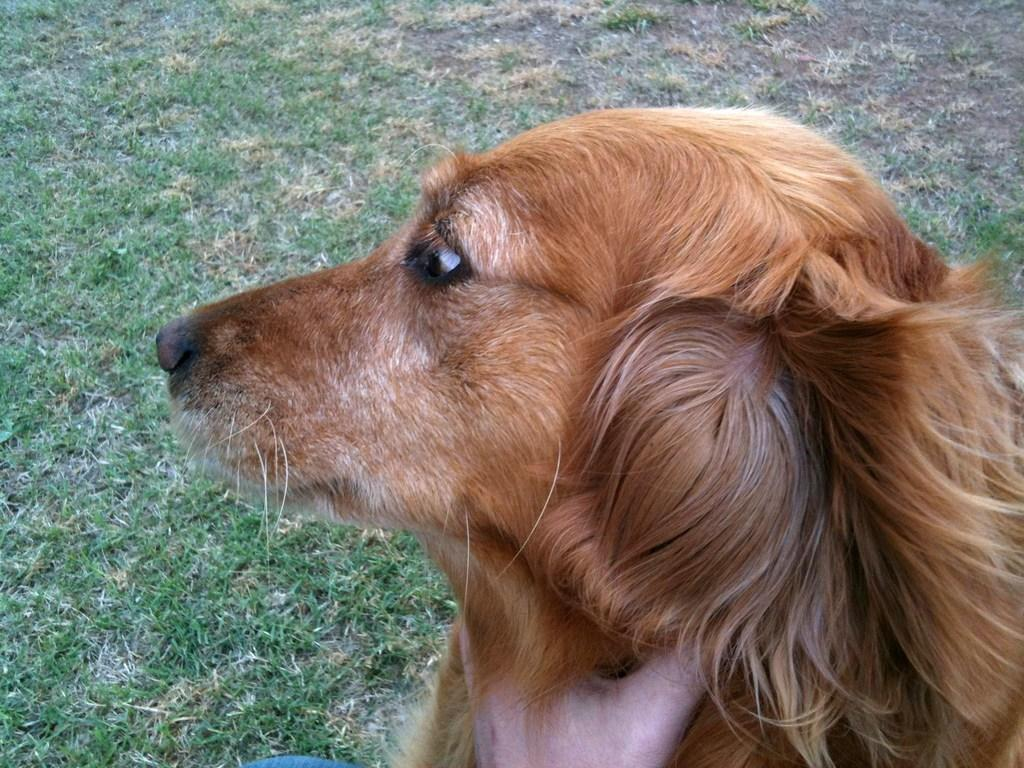What animal can be seen in the image? There is a dog in the image. Where is the dog located? The dog is on the grass. What type of judge is overseeing the sorting and ordering of the dog in the image? There is no judge or sorting and ordering of the dog in the image; it is simply a dog on the grass. 